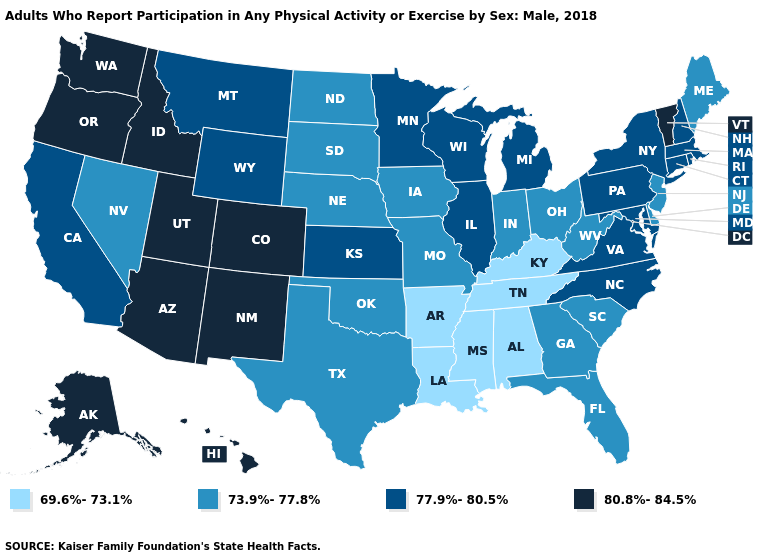What is the lowest value in the USA?
Short answer required. 69.6%-73.1%. What is the value of Delaware?
Write a very short answer. 73.9%-77.8%. What is the value of Pennsylvania?
Answer briefly. 77.9%-80.5%. Does Georgia have the lowest value in the USA?
Be succinct. No. What is the value of West Virginia?
Write a very short answer. 73.9%-77.8%. Name the states that have a value in the range 73.9%-77.8%?
Answer briefly. Delaware, Florida, Georgia, Indiana, Iowa, Maine, Missouri, Nebraska, Nevada, New Jersey, North Dakota, Ohio, Oklahoma, South Carolina, South Dakota, Texas, West Virginia. Does Oregon have the highest value in the West?
Answer briefly. Yes. Does Nevada have the same value as Michigan?
Concise answer only. No. Which states have the lowest value in the USA?
Be succinct. Alabama, Arkansas, Kentucky, Louisiana, Mississippi, Tennessee. What is the value of Montana?
Keep it brief. 77.9%-80.5%. Does the map have missing data?
Keep it brief. No. What is the value of Georgia?
Quick response, please. 73.9%-77.8%. Does the first symbol in the legend represent the smallest category?
Write a very short answer. Yes. Does Iowa have a lower value than Virginia?
Write a very short answer. Yes. What is the value of Utah?
Quick response, please. 80.8%-84.5%. 